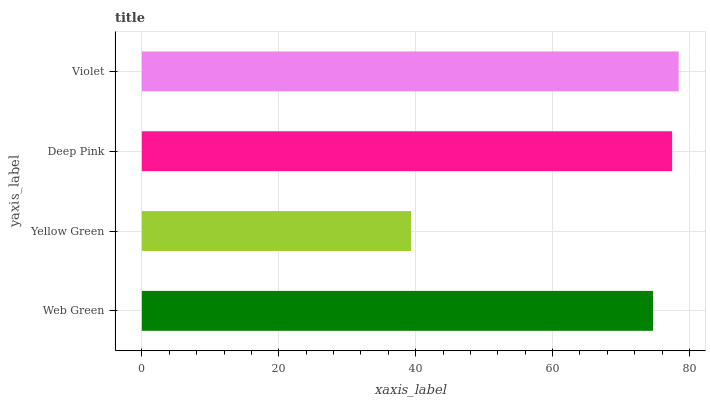Is Yellow Green the minimum?
Answer yes or no. Yes. Is Violet the maximum?
Answer yes or no. Yes. Is Deep Pink the minimum?
Answer yes or no. No. Is Deep Pink the maximum?
Answer yes or no. No. Is Deep Pink greater than Yellow Green?
Answer yes or no. Yes. Is Yellow Green less than Deep Pink?
Answer yes or no. Yes. Is Yellow Green greater than Deep Pink?
Answer yes or no. No. Is Deep Pink less than Yellow Green?
Answer yes or no. No. Is Deep Pink the high median?
Answer yes or no. Yes. Is Web Green the low median?
Answer yes or no. Yes. Is Yellow Green the high median?
Answer yes or no. No. Is Violet the low median?
Answer yes or no. No. 